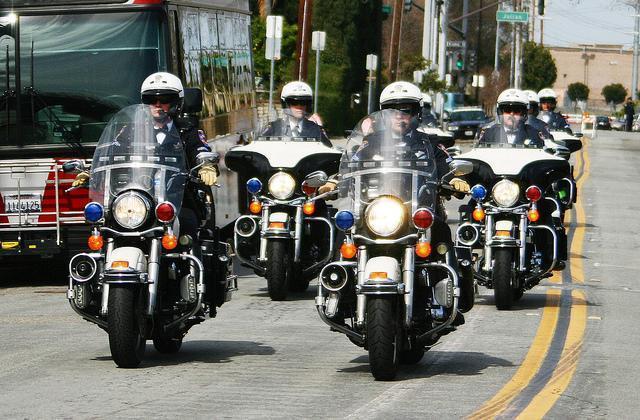How many motorcycles are there?
Give a very brief answer. 4. How many people can you see?
Give a very brief answer. 4. 